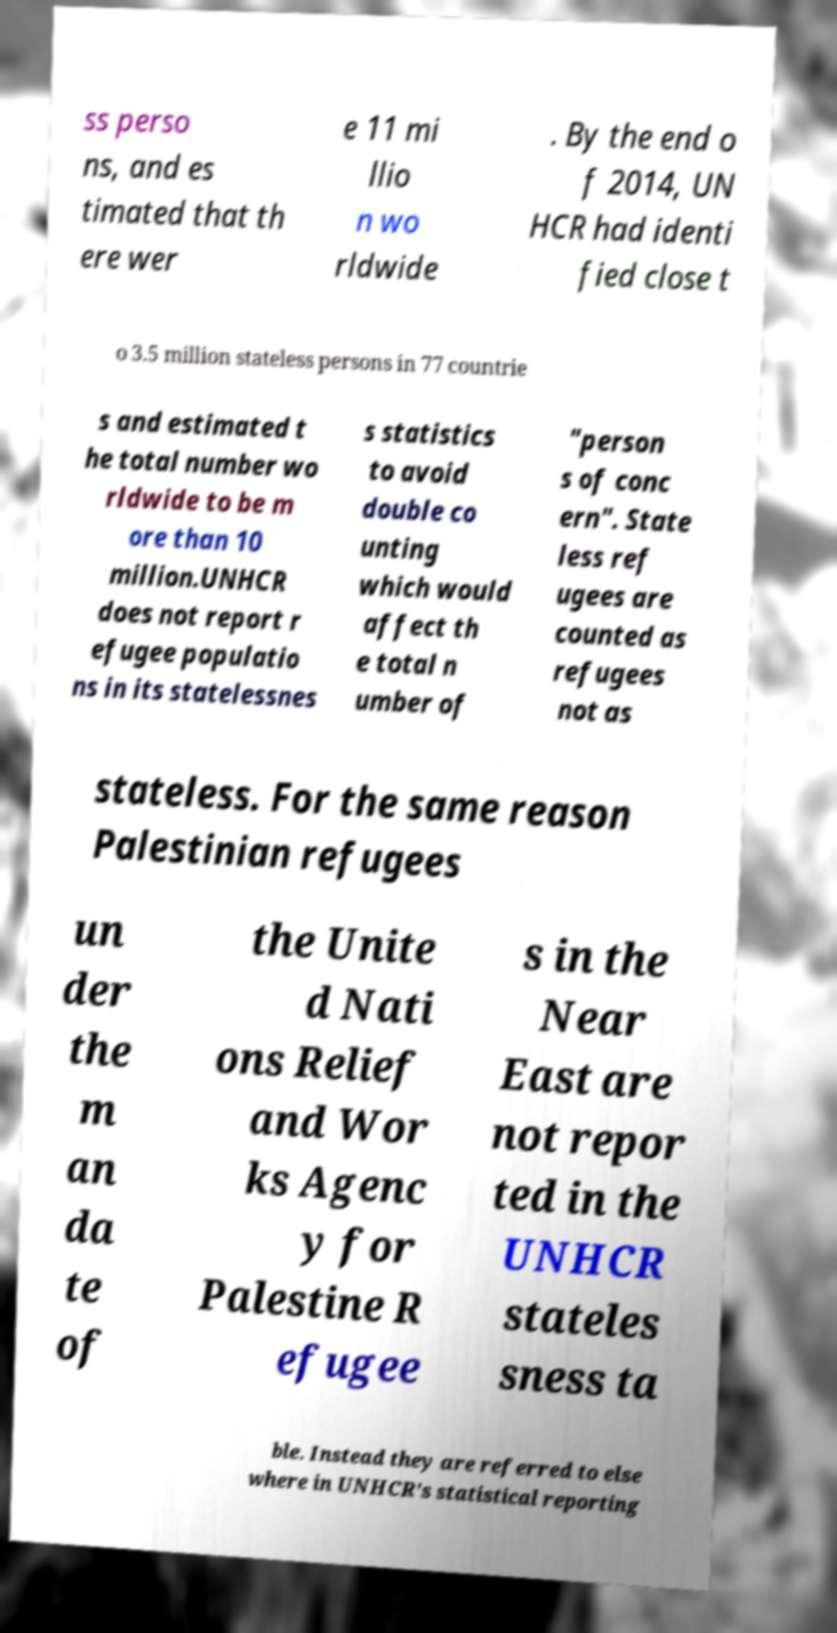Could you assist in decoding the text presented in this image and type it out clearly? ss perso ns, and es timated that th ere wer e 11 mi llio n wo rldwide . By the end o f 2014, UN HCR had identi fied close t o 3.5 million stateless persons in 77 countrie s and estimated t he total number wo rldwide to be m ore than 10 million.UNHCR does not report r efugee populatio ns in its statelessnes s statistics to avoid double co unting which would affect th e total n umber of "person s of conc ern". State less ref ugees are counted as refugees not as stateless. For the same reason Palestinian refugees un der the m an da te of the Unite d Nati ons Relief and Wor ks Agenc y for Palestine R efugee s in the Near East are not repor ted in the UNHCR stateles sness ta ble. Instead they are referred to else where in UNHCR's statistical reporting 